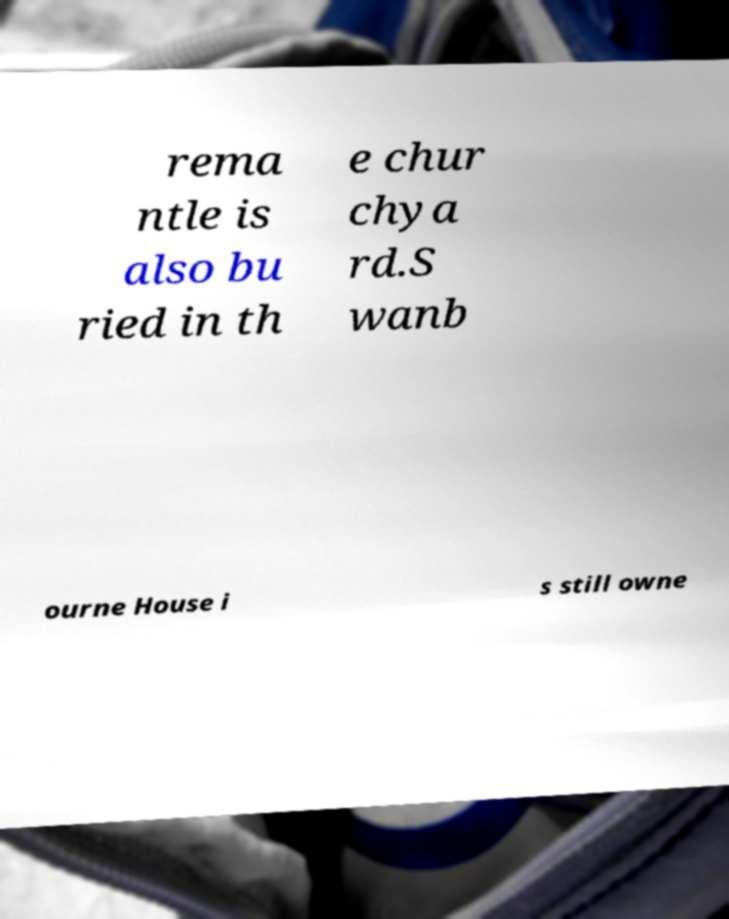For documentation purposes, I need the text within this image transcribed. Could you provide that? rema ntle is also bu ried in th e chur chya rd.S wanb ourne House i s still owne 